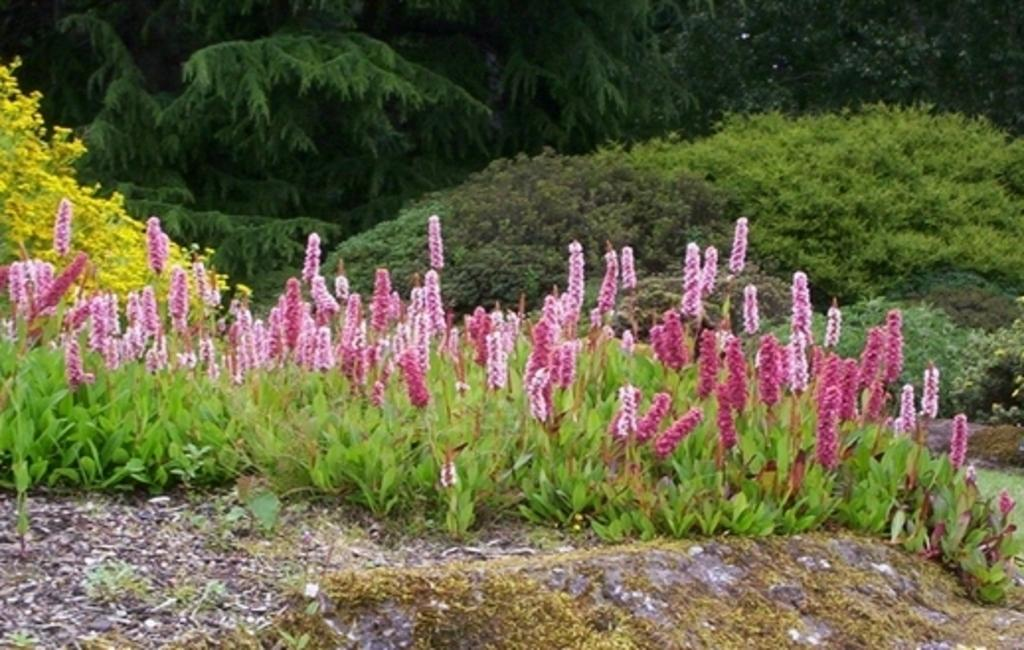What type of vegetation can be seen in the image? There are flowers on plants, bushes, and trees in the image. Can you describe the different types of plants in the image? The image contains flowers on plants, bushes, and trees. What is the predominant color of the vegetation in the image? The predominant color of the vegetation in the image is green, with some flowers providing additional colors. What type of cake is being served on the plate in the image? There is no plate or cake present in the image; it features vegetation such as flowers on plants, bushes, and trees. 